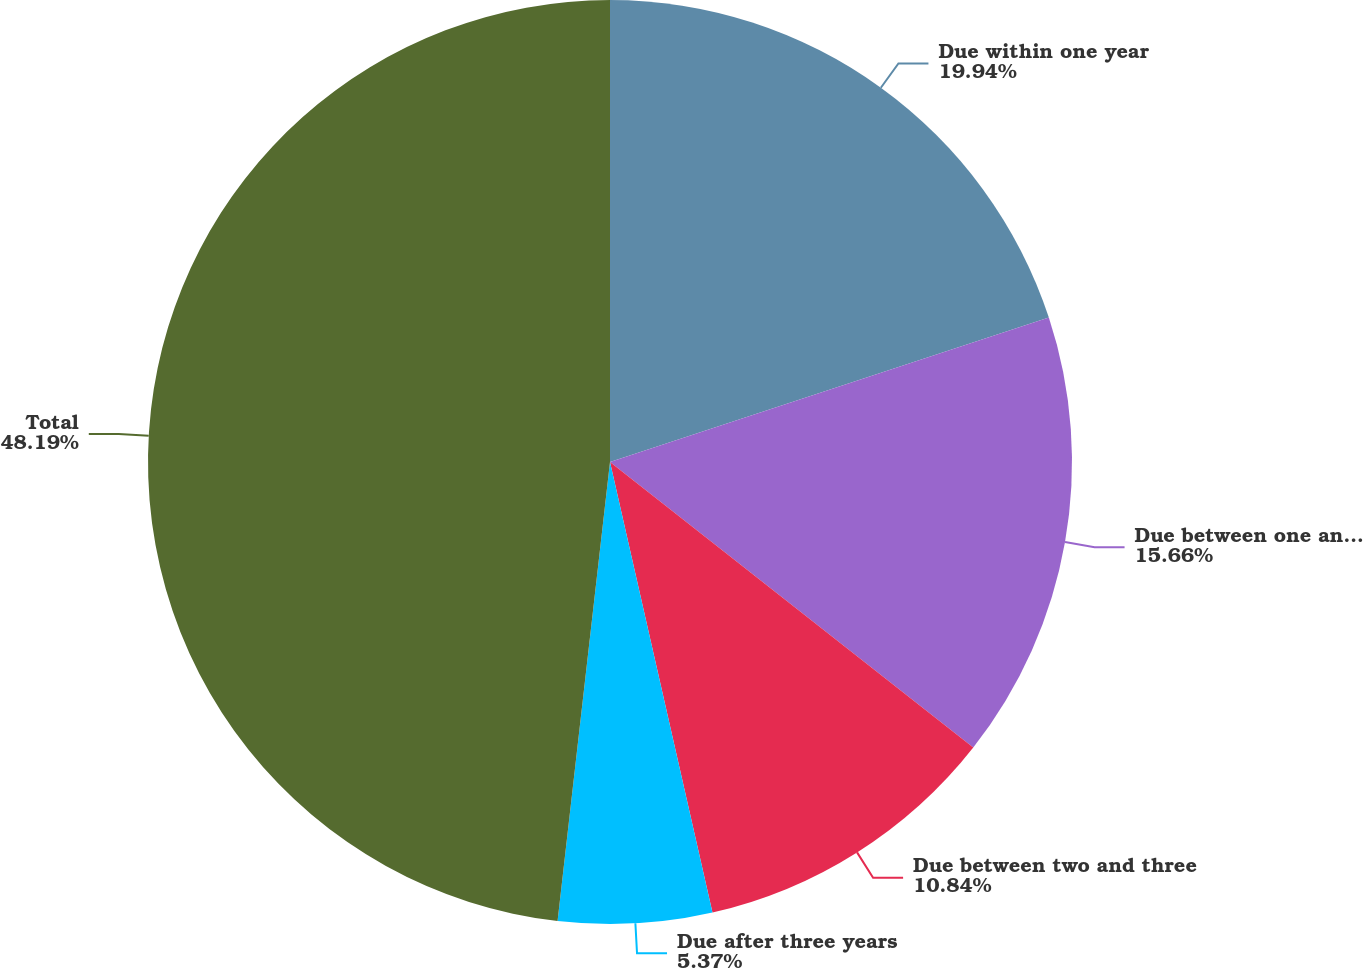Convert chart. <chart><loc_0><loc_0><loc_500><loc_500><pie_chart><fcel>Due within one year<fcel>Due between one and two years<fcel>Due between two and three<fcel>Due after three years<fcel>Total<nl><fcel>19.94%<fcel>15.66%<fcel>10.84%<fcel>5.37%<fcel>48.19%<nl></chart> 